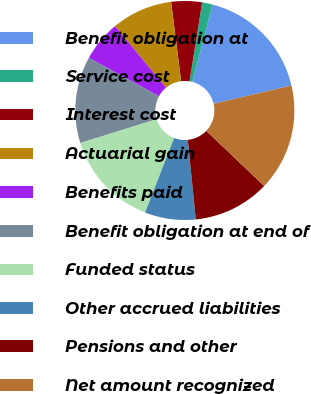Convert chart. <chart><loc_0><loc_0><loc_500><loc_500><pie_chart><fcel>Benefit obligation at<fcel>Service cost<fcel>Interest cost<fcel>Actuarial gain<fcel>Benefits paid<fcel>Benefit obligation at end of<fcel>Funded status<fcel>Other accrued liabilities<fcel>Pensions and other<fcel>Net amount recognized<nl><fcel>17.26%<fcel>1.55%<fcel>4.53%<fcel>9.0%<fcel>6.02%<fcel>12.79%<fcel>14.28%<fcel>7.51%<fcel>11.3%<fcel>15.77%<nl></chart> 